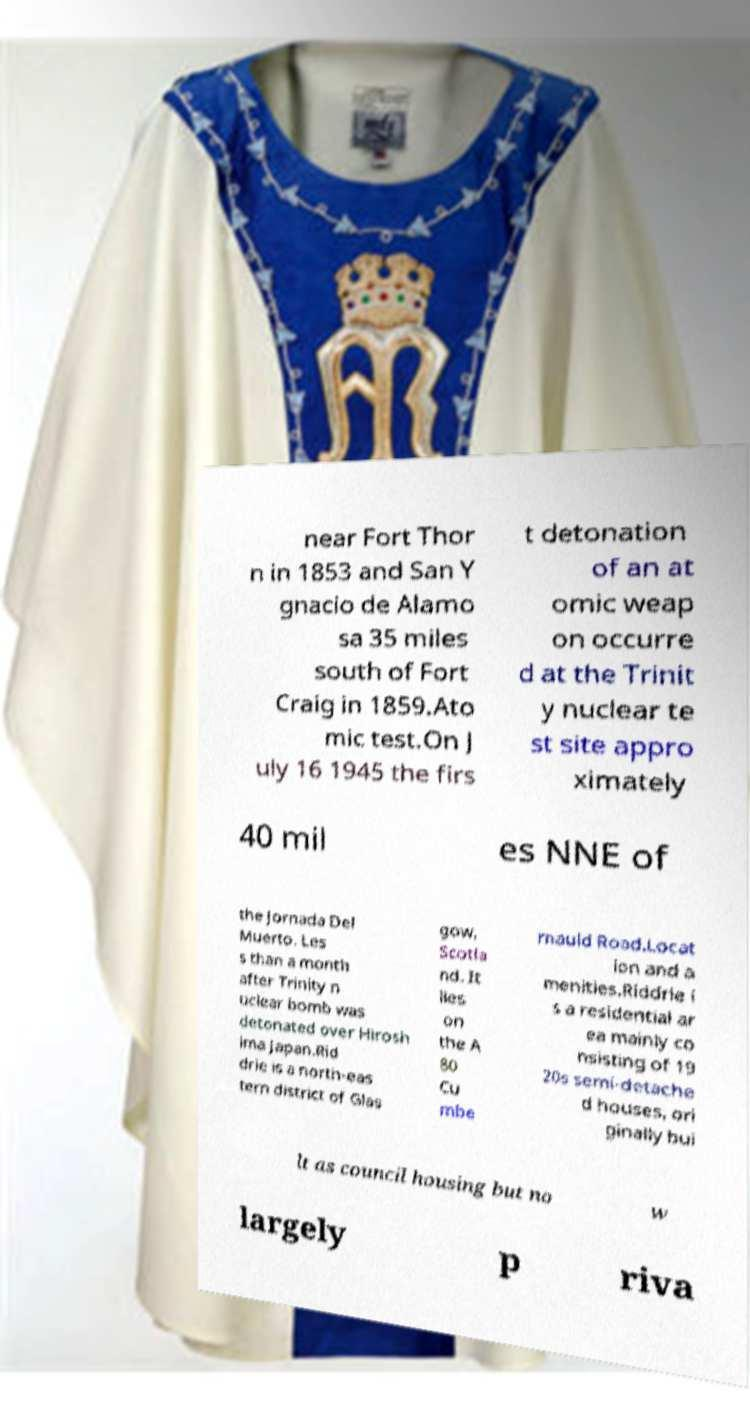Please identify and transcribe the text found in this image. near Fort Thor n in 1853 and San Y gnacio de Alamo sa 35 miles south of Fort Craig in 1859.Ato mic test.On J uly 16 1945 the firs t detonation of an at omic weap on occurre d at the Trinit y nuclear te st site appro ximately 40 mil es NNE of the Jornada Del Muerto. Les s than a month after Trinity n uclear bomb was detonated over Hirosh ima Japan.Rid drie is a north-eas tern district of Glas gow, Scotla nd. It lies on the A 80 Cu mbe rnauld Road.Locat ion and a menities.Riddrie i s a residential ar ea mainly co nsisting of 19 20s semi-detache d houses, ori ginally bui lt as council housing but no w largely p riva 